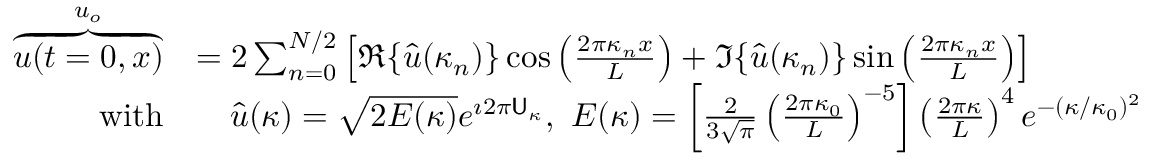<formula> <loc_0><loc_0><loc_500><loc_500>\begin{array} { r l } { \overbrace { u ( t = 0 , x ) } ^ { u _ { o } } } & { = 2 \sum _ { n = 0 } ^ { N / 2 } \left [ \Re \{ \hat { u } ( \kappa _ { n } ) \} \cos \left ( \frac { 2 \pi \kappa _ { n } x } { L } \right ) + \Im \{ \hat { u } ( \kappa _ { n } ) \} \sin \left ( \frac { 2 \pi \kappa _ { n } x } { L } \right ) \right ] } \\ { w i t h } & { \quad \hat { u } ( \kappa ) = \sqrt { 2 E ( \kappa ) } e ^ { \imath 2 \pi U _ { \kappa } } , \ E ( \kappa ) = \left [ \frac { 2 } { 3 \sqrt { \pi } } \left ( \frac { 2 \pi \kappa _ { 0 } } { L } \right ) ^ { - 5 } \right ] \left ( \frac { 2 \pi \kappa } { L } \right ) ^ { 4 } e ^ { - ( \kappa / \kappa _ { 0 } ) ^ { 2 } } } \end{array}</formula> 